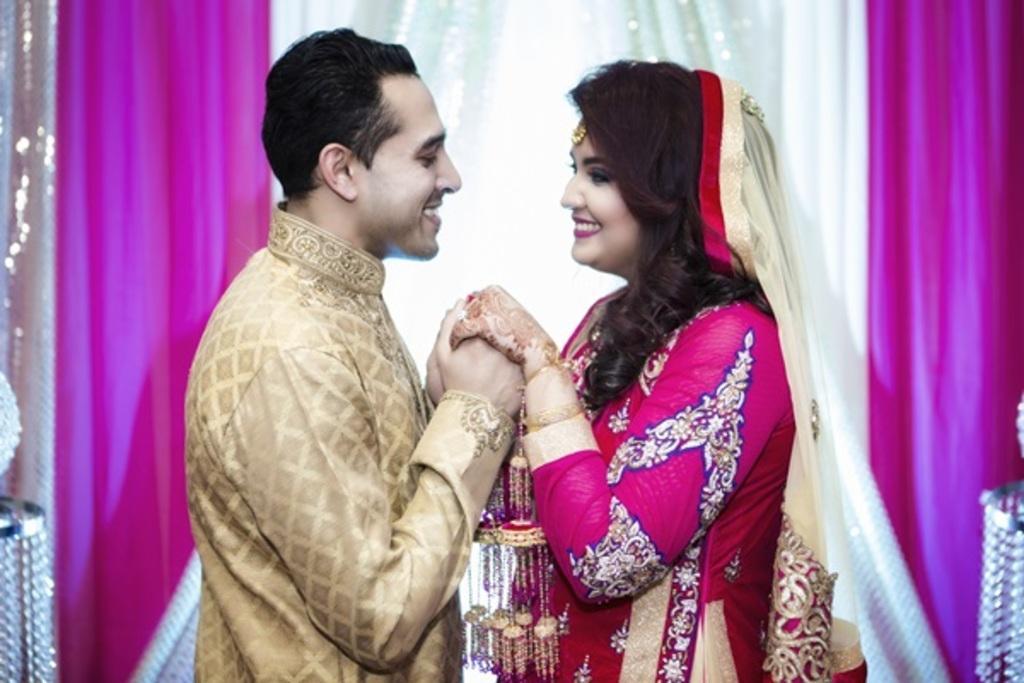Can you describe this image briefly? Here we can see a man and a woman holding their hands each other. In the background we can see clothes. 